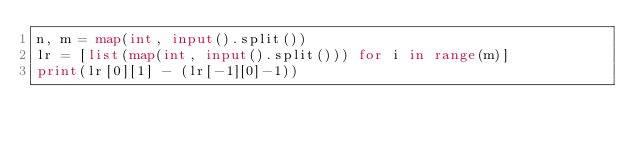Convert code to text. <code><loc_0><loc_0><loc_500><loc_500><_Python_>n, m = map(int, input().split())
lr = [list(map(int, input().split())) for i in range(m)]
print(lr[0][1] - (lr[-1][0]-1))
</code> 